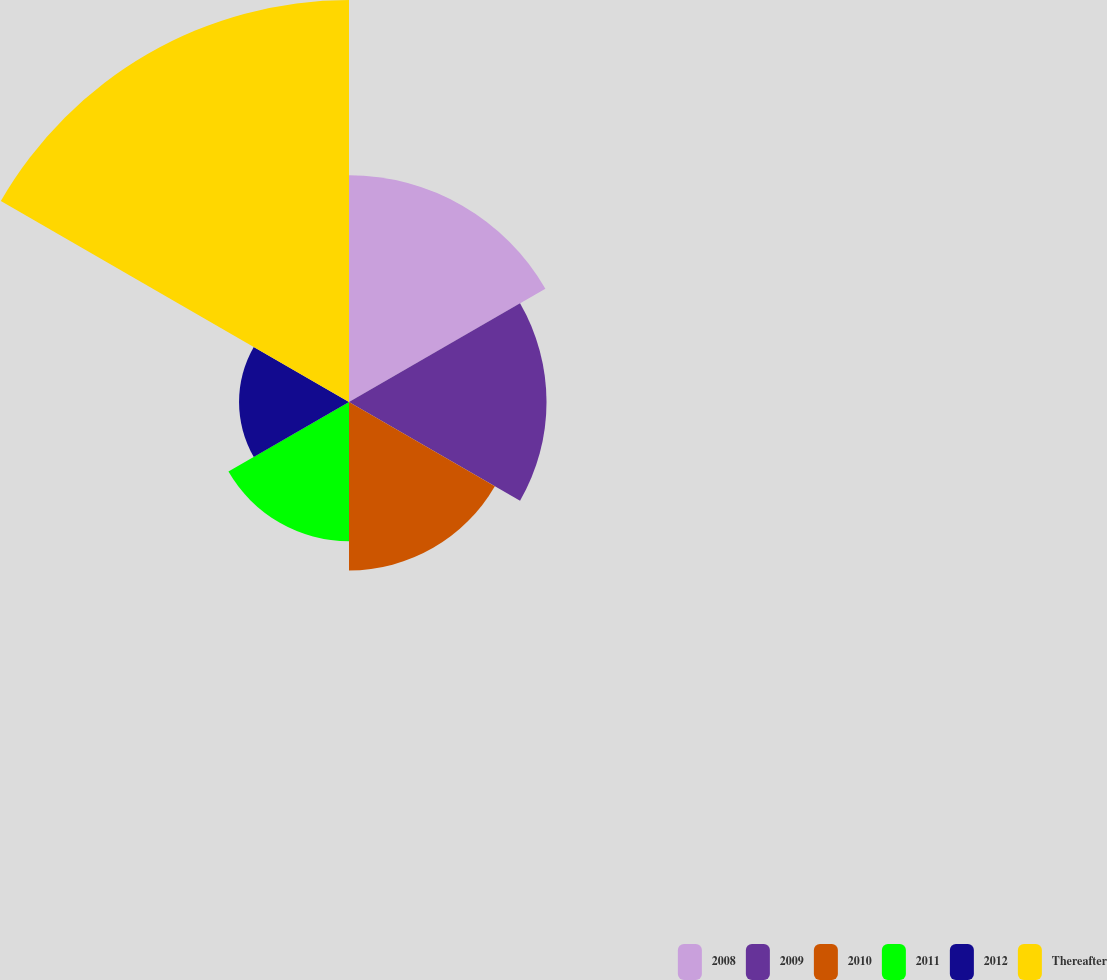Convert chart. <chart><loc_0><loc_0><loc_500><loc_500><pie_chart><fcel>2008<fcel>2009<fcel>2010<fcel>2011<fcel>2012<fcel>Thereafter<nl><fcel>18.23%<fcel>15.88%<fcel>13.54%<fcel>11.19%<fcel>8.84%<fcel>32.32%<nl></chart> 